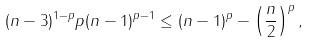<formula> <loc_0><loc_0><loc_500><loc_500>( n - 3 ) ^ { 1 - p } p ( n - 1 ) ^ { p - 1 } \leq ( n - 1 ) ^ { p } - \left ( \frac { n } { 2 } \right ) ^ { p } ,</formula> 